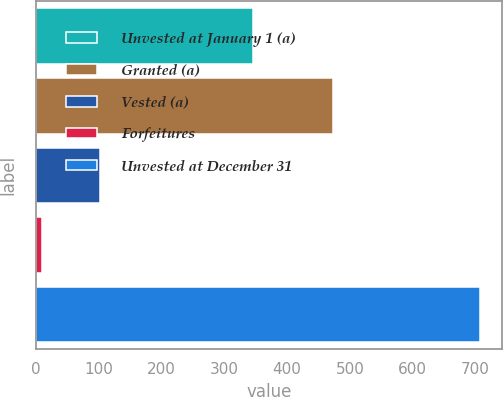Convert chart. <chart><loc_0><loc_0><loc_500><loc_500><bar_chart><fcel>Unvested at January 1 (a)<fcel>Granted (a)<fcel>Vested (a)<fcel>Forfeitures<fcel>Unvested at December 31<nl><fcel>346<fcel>473<fcel>102<fcel>10<fcel>707<nl></chart> 